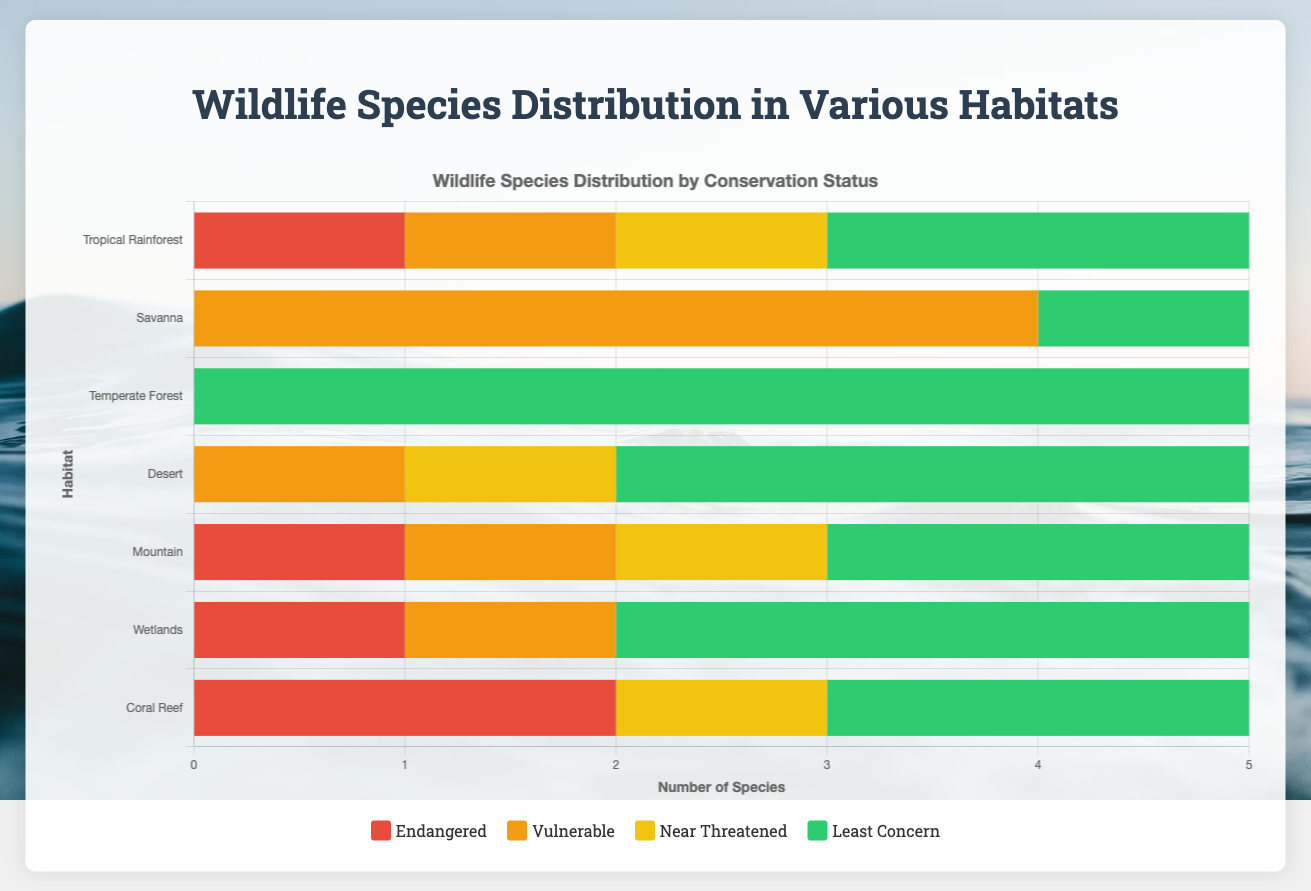What habitat has the greatest number of species listed as "least concern"? To find the habitat with the greatest number of species listed as "least concern," look at the green bars representing "least concern" and compare their lengths across all habitats. The longest green bar indicates the highest count. The Temperate Forest habitat has the longest green bar.
Answer: Temperate Forest How many endangered species are there in the Coral Reef habitat? Identify the red bar for the Coral Reef habitat. The length of this red bar shows the count of endangered species. The Coral Reef habitat has two red bars for endangered species.
Answer: 2 Which habitats have more than one species listed as "vulnerable"? Check the yellow bars representing "vulnerable" species for each habitat. If any habitat has a yellow bar with a length greater than 1, it means there are more than one vulnerable species. The Savanna habitat has four "vulnerable" species, and the Mountain habitat has one "vulnerable" species.
Answer: Savanna What is the total number of "endangered" species across all habitats? Add the lengths of all red bars representing "endangered" species for each habitat: 1 (Tropical Rainforest) + 0 (Savanna) + 0 (Temperate Forest) + 0 (Desert) + 1 (Mountain) + 1 (Wetlands) + 2 (Coral Reef). This results in 5 endangered species.
Answer: 5 Compare the total number of "near threatened" species in the Tropical Rainforest and Coral Reef habitats. Which has more? Compare the lengths of the yellow bars (representing "near threatened") for the Tropical Rainforest and Coral Reef habitats. The Tropical Rainforest has one "near threatened" species, and the Coral Reef also has one.
Answer: Equal How many species in the Wetlands habitat are either "vulnerable" or "endangered"? Look at the yellow and red portions of the bar for the Wetlands habitat. There are 1 "vulnerable" species represented by the yellow bar, and 1 "endangered" species represented by the red bar. Therefore, the total is 1+1=2.
Answer: 2 Which habitat has the least number of total species? Calculate the total length of the bars for each habitat. The sum of values for each species status will indicate the total number of species in each habitat. The Desert habitat has the smallest total length bar representing five species.
Answer: Desert 